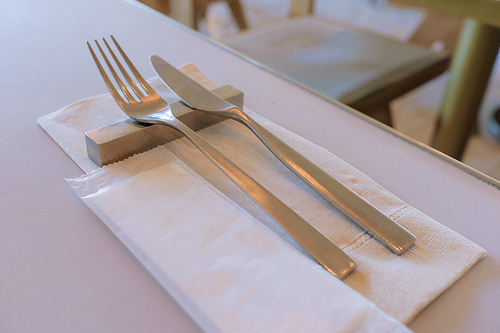<image>
Can you confirm if the fork is on the knife? No. The fork is not positioned on the knife. They may be near each other, but the fork is not supported by or resting on top of the knife. 